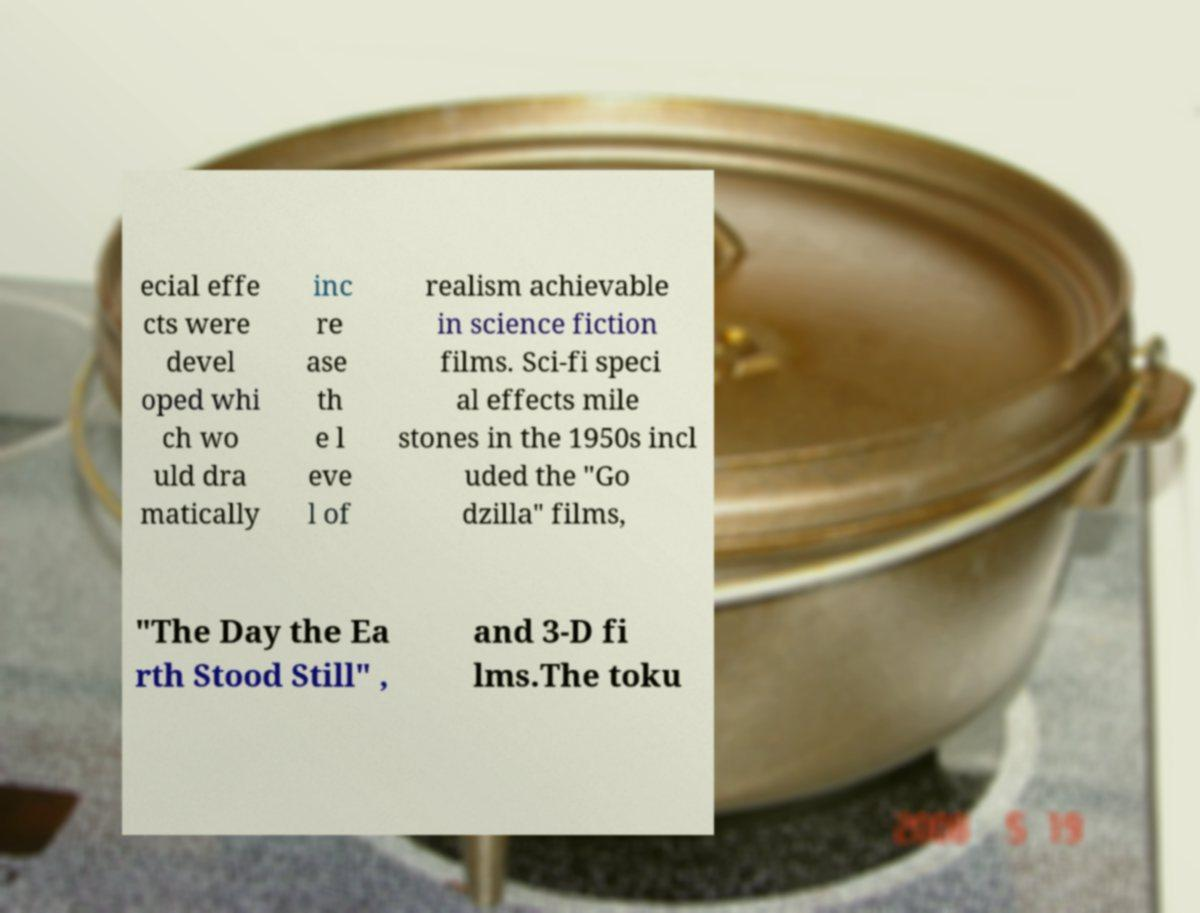Please identify and transcribe the text found in this image. ecial effe cts were devel oped whi ch wo uld dra matically inc re ase th e l eve l of realism achievable in science fiction films. Sci-fi speci al effects mile stones in the 1950s incl uded the "Go dzilla" films, "The Day the Ea rth Stood Still" , and 3-D fi lms.The toku 